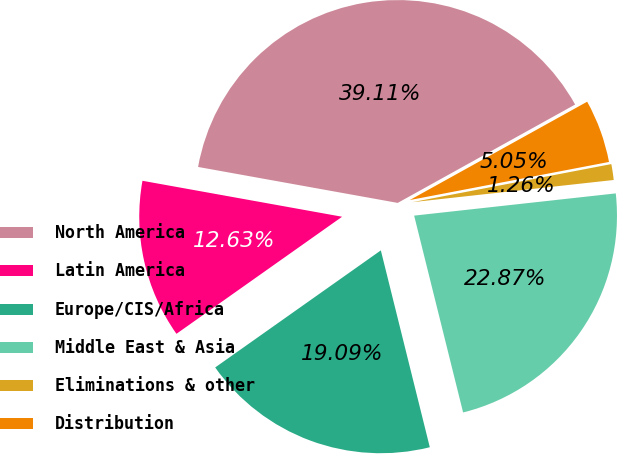<chart> <loc_0><loc_0><loc_500><loc_500><pie_chart><fcel>North America<fcel>Latin America<fcel>Europe/CIS/Africa<fcel>Middle East & Asia<fcel>Eliminations & other<fcel>Distribution<nl><fcel>39.11%<fcel>12.63%<fcel>19.09%<fcel>22.87%<fcel>1.26%<fcel>5.05%<nl></chart> 